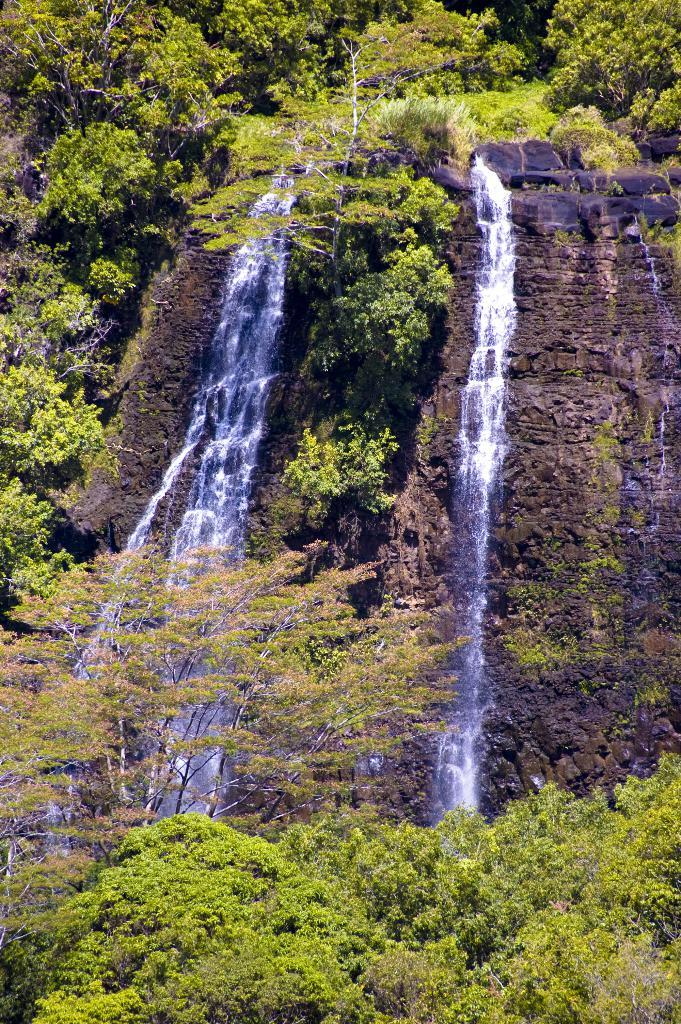What type of natural feature can be seen in the image? There are trees in the image. What specific water feature is visible in the image? There is a waterfall visible in the image. What type of joke is being told by the mine in the image? There is no mine or joke present in the image; it features trees and a waterfall. 